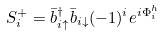Convert formula to latex. <formula><loc_0><loc_0><loc_500><loc_500>S ^ { + } _ { i } = \bar { b } ^ { \dagger } _ { i \uparrow } \bar { b } _ { i \downarrow } ( - 1 ) ^ { i } e ^ { i \Phi _ { i } ^ { h } }</formula> 